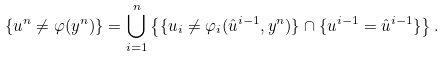<formula> <loc_0><loc_0><loc_500><loc_500>\{ u ^ { n } \ne \varphi ( y ^ { n } ) \} = \bigcup _ { i = 1 } ^ { n } \left \{ \{ u _ { i } \ne \varphi _ { i } ( \hat { u } ^ { i - 1 } , y ^ { n } ) \} \cap \{ u ^ { i - 1 } = \hat { u } ^ { i - 1 } \} \right \} .</formula> 